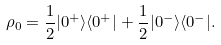<formula> <loc_0><loc_0><loc_500><loc_500>\rho _ { 0 } = \frac { 1 } { 2 } | 0 ^ { + } \rangle \langle 0 ^ { + } | + \frac { 1 } { 2 } | 0 ^ { - } \rangle \langle 0 ^ { - } | .</formula> 